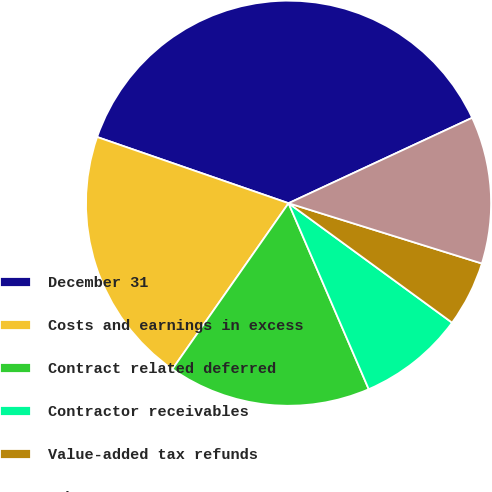Convert chart to OTSL. <chart><loc_0><loc_0><loc_500><loc_500><pie_chart><fcel>December 31<fcel>Costs and earnings in excess<fcel>Contract related deferred<fcel>Contractor receivables<fcel>Value-added tax refunds<fcel>Other<nl><fcel>37.77%<fcel>20.58%<fcel>16.2%<fcel>8.48%<fcel>5.23%<fcel>11.74%<nl></chart> 